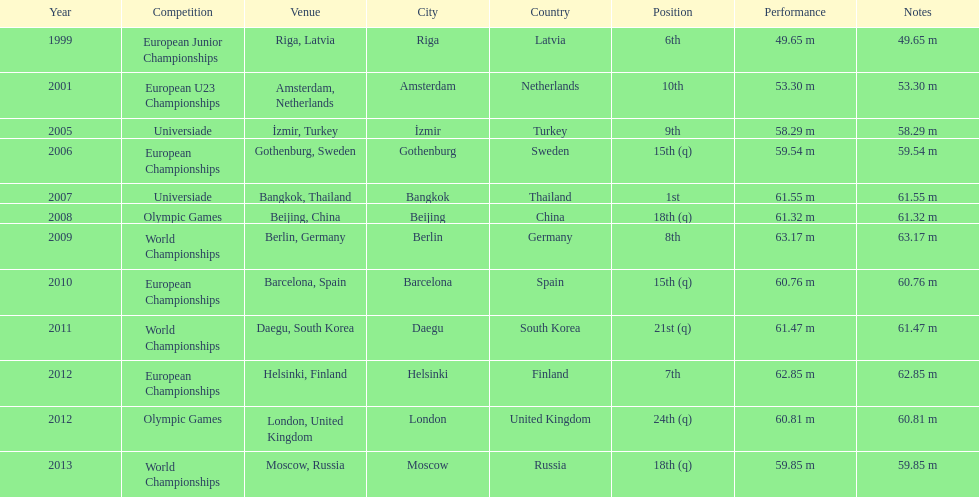30m accomplished? 2001. 